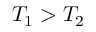<formula> <loc_0><loc_0><loc_500><loc_500>T _ { 1 } > T _ { 2 }</formula> 